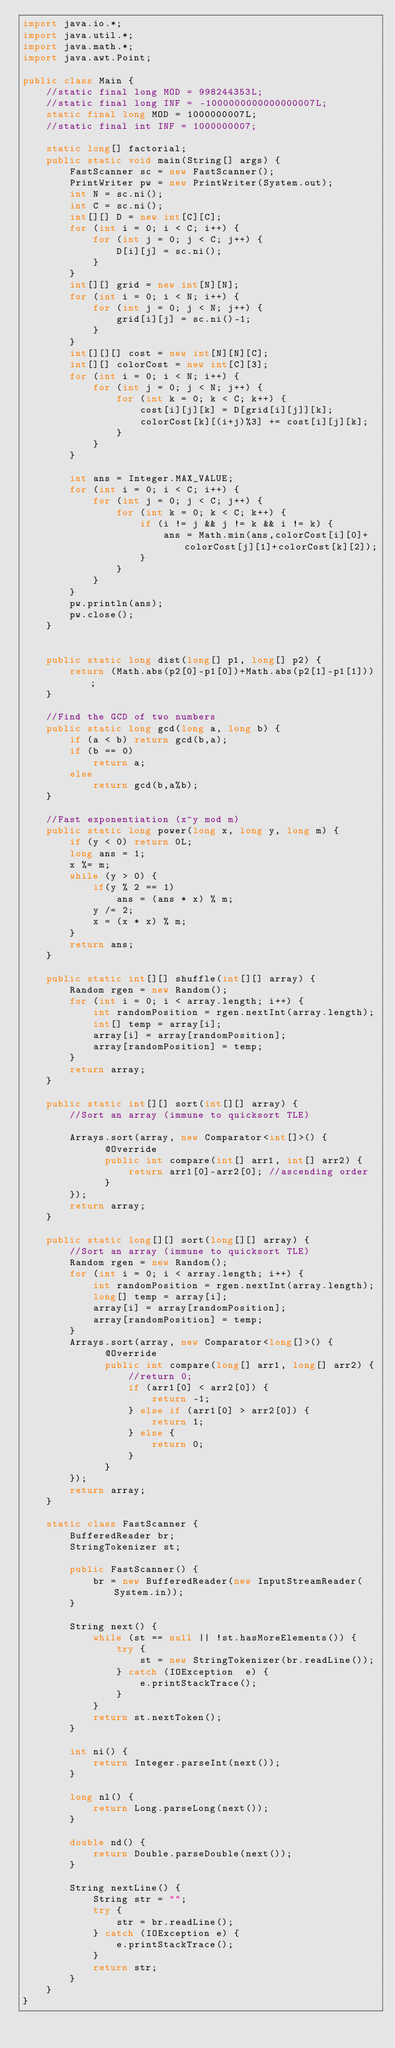<code> <loc_0><loc_0><loc_500><loc_500><_Java_>import java.io.*;
import java.util.*;
import java.math.*;
import java.awt.Point;
 
public class Main {
	//static final long MOD = 998244353L;
	//static final long INF = -1000000000000000007L;
	static final long MOD = 1000000007L;
	//static final int INF = 1000000007;
	
	static long[] factorial;
	public static void main(String[] args) {
		FastScanner sc = new FastScanner();
		PrintWriter pw = new PrintWriter(System.out);
		int N = sc.ni();
		int C = sc.ni();
		int[][] D = new int[C][C];
		for (int i = 0; i < C; i++) {
			for (int j = 0; j < C; j++) {
				D[i][j] = sc.ni();
			}
		}
		int[][] grid = new int[N][N];
		for (int i = 0; i < N; i++) {
			for (int j = 0; j < N; j++) {
				grid[i][j] = sc.ni()-1;
			}
		}
		int[][][] cost = new int[N][N][C];
		int[][] colorCost = new int[C][3];
		for (int i = 0; i < N; i++) {
			for (int j = 0; j < N; j++) {
				for (int k = 0; k < C; k++) {
					cost[i][j][k] = D[grid[i][j]][k];
					colorCost[k][(i+j)%3] += cost[i][j][k];
				}
			}
		}
		
		int ans = Integer.MAX_VALUE;
		for (int i = 0; i < C; i++) {
			for (int j = 0; j < C; j++) {
				for (int k = 0; k < C; k++) {
					if (i != j && j != k && i != k) {
						ans = Math.min(ans,colorCost[i][0]+colorCost[j][1]+colorCost[k][2]);
					}
				}
			}
		}
		pw.println(ans);
		pw.close();
	}

	
	public static long dist(long[] p1, long[] p2) {
		return (Math.abs(p2[0]-p1[0])+Math.abs(p2[1]-p1[1]));
	}
	
	//Find the GCD of two numbers
	public static long gcd(long a, long b) {
		if (a < b) return gcd(b,a);
		if (b == 0)
			return a;
		else
			return gcd(b,a%b);
	}
	
	//Fast exponentiation (x^y mod m)
	public static long power(long x, long y, long m) { 
		if (y < 0) return 0L;
		long ans = 1;
		x %= m;
		while (y > 0) { 
			if(y % 2 == 1) 
				ans = (ans * x) % m; 
			y /= 2;  
			x = (x * x) % m;
		} 
		return ans; 
	}
	
	public static int[][] shuffle(int[][] array) {
		Random rgen = new Random();
		for (int i = 0; i < array.length; i++) {
		    int randomPosition = rgen.nextInt(array.length);
		    int[] temp = array[i];
		    array[i] = array[randomPosition];
		    array[randomPosition] = temp;
		}
		return array;
	}
	
    public static int[][] sort(int[][] array) {
    	//Sort an array (immune to quicksort TLE)
 
		Arrays.sort(array, new Comparator<int[]>() {
			  @Override
        	  public int compare(int[] arr1, int[] arr2) {
				  return arr1[0]-arr2[0]; //ascending order
	          }
		});
		return array;
	}
    
    public static long[][] sort(long[][] array) {
    	//Sort an array (immune to quicksort TLE)
		Random rgen = new Random();
		for (int i = 0; i < array.length; i++) {
		    int randomPosition = rgen.nextInt(array.length);
		    long[] temp = array[i];
		    array[i] = array[randomPosition];
		    array[randomPosition] = temp;
		}
		Arrays.sort(array, new Comparator<long[]>() {
			  @Override
        	  public int compare(long[] arr1, long[] arr2) {
				  //return 0;
				  if (arr1[0] < arr2[0]) {
					  return -1;
				  } else if (arr1[0] > arr2[0]) {
					  return 1;
				  } else {
					  return 0;
				  }
	          }
		});
		return array;
	}
    
    static class FastScanner { 
        BufferedReader br; 
        StringTokenizer st; 
  
        public FastScanner() { 
            br = new BufferedReader(new InputStreamReader(System.in)); 
        } 
  
        String next() { 
            while (st == null || !st.hasMoreElements()) { 
                try { 
                    st = new StringTokenizer(br.readLine());
                } catch (IOException  e) { 
                    e.printStackTrace(); 
                } 
            } 
            return st.nextToken(); 
        } 
  
        int ni() { 
            return Integer.parseInt(next()); 
        } 
  
        long nl() { 
            return Long.parseLong(next()); 
        } 
  
        double nd() { 
            return Double.parseDouble(next()); 
        } 
  
        String nextLine() { 
            String str = ""; 
            try { 
                str = br.readLine(); 
            } catch (IOException e) {
                e.printStackTrace(); 
            } 
            return str;
        }
    }
}</code> 